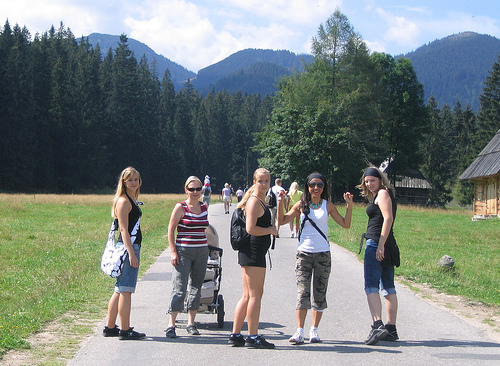<image>
Is there a stroller in the backpack? No. The stroller is not contained within the backpack. These objects have a different spatial relationship. 